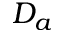<formula> <loc_0><loc_0><loc_500><loc_500>D _ { a }</formula> 